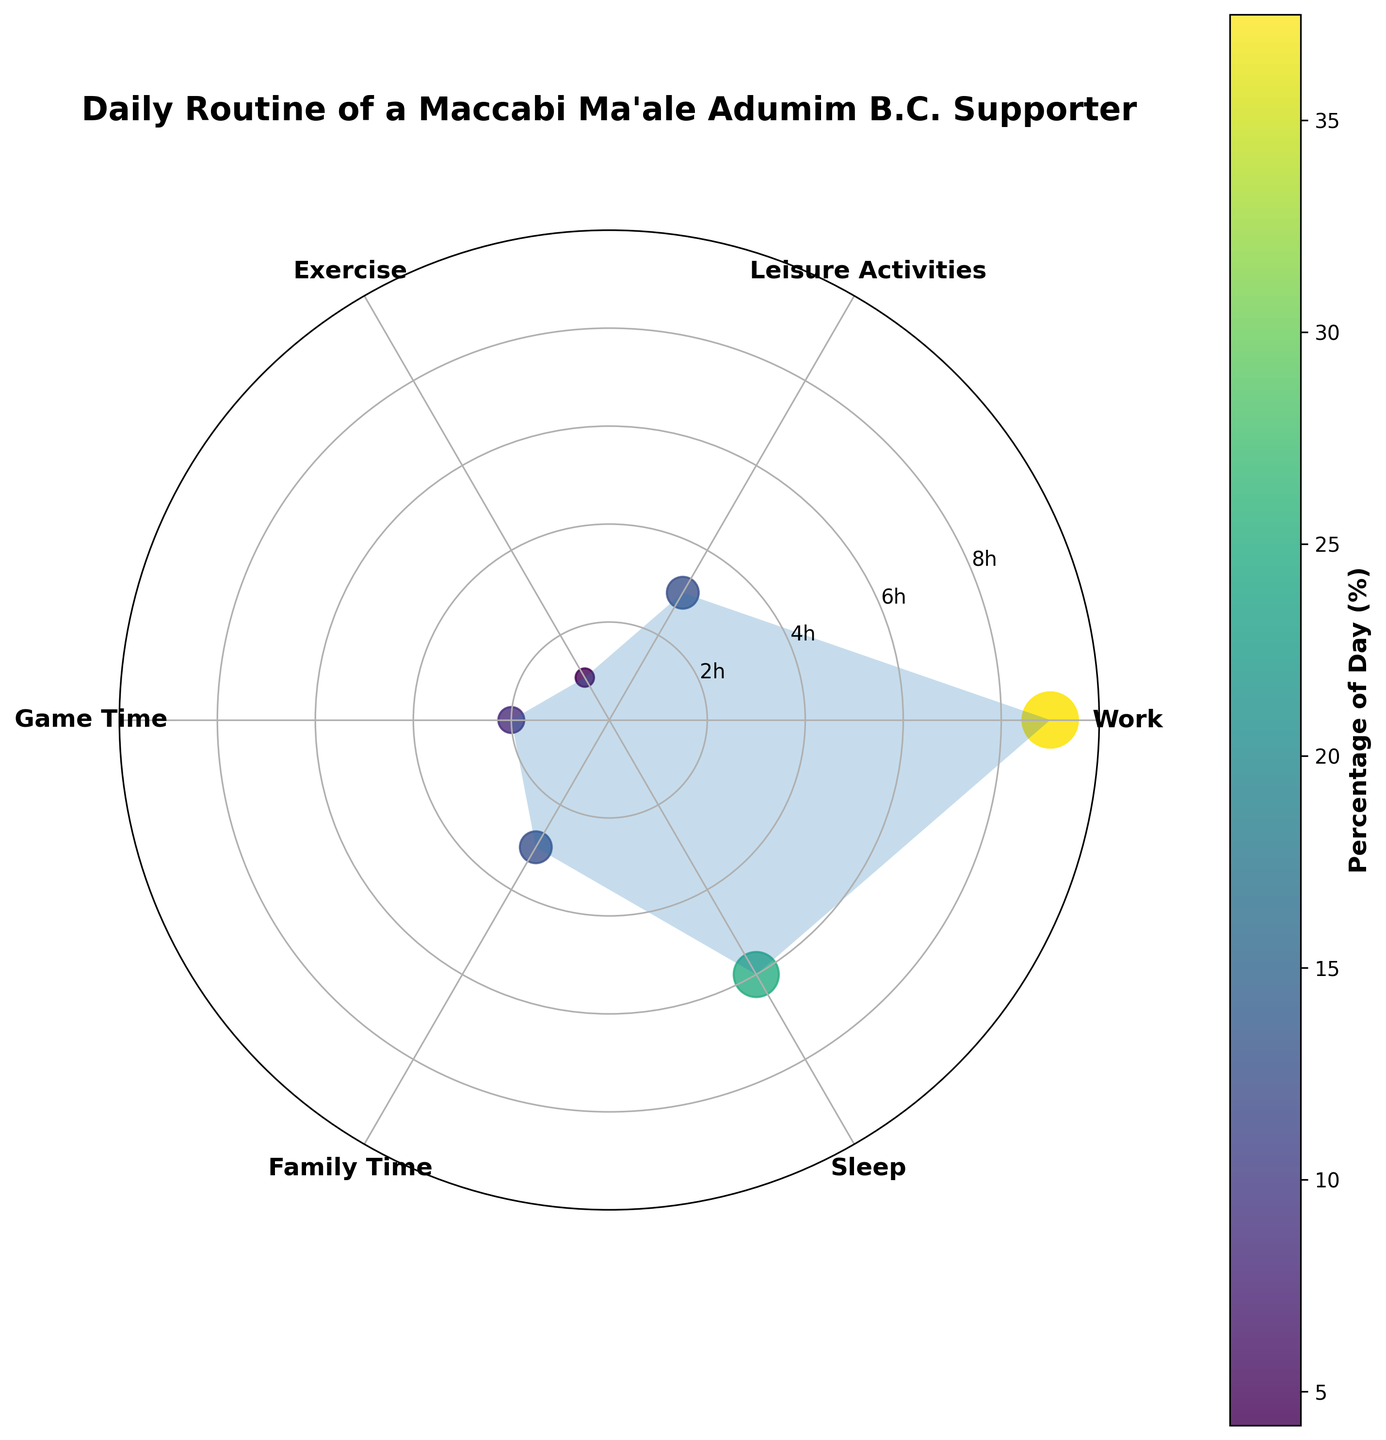Is "Work" the category with the highest number of hours spent? The figure shows different categories labeled around the polar chart with their corresponding hours marked by radial distances. "Work" appears to extend the furthest radially, indicating the highest number of hours spent.
Answer: Yes How many hours are spent on "Exercise"? The figure has radial labels indicating hours, and "Exercise" corresponds to the inner-most radial distance, indicating 1 hour spent.
Answer: 1 hour Which category occupies 25% of the day? The colorbar indicates the percentage of the day, and "Sleep" is color-coded to match the 25% label on the colorbar.
Answer: Sleep What is the total number of hours spent on "Leisure Activities" and "Game Time"? From the figure, "Leisure Activities" is indicated at 3 hours, and "Game Time" is at 2 hours. Summing these gives 3 + 2 = 5 hours.
Answer: 5 hours Is "Family Time" represented equally to any other category in terms of percentage of the day? From the percentages on the colorbar and the figure, "Family Time" (12.5%) is equal to "Leisure Activities" (12.5%).
Answer: Leisure Activities Which category is represented by the smallest circle in the scatter plot? The size of circles on the scatter plot corresponds to the percentage of the day. The smallest circle, being the smallest proportion, is for "Exercise" at 4.2%.
Answer: Exercise How do the hours spent on "Sleep" compare to those spent on "Work"? The polar scatter chart shows "Sleep" at 6 hours and "Work" at 9 hours. Comparing these, "Work" has 3 more hours than "Sleep".
Answer: Work has 3 more hours What is the average number of hours spent on "Game Time" and "Family Time"? From the chart, "Game Time" is 2 hours, and "Family Time" is 3 hours. The average is calculated by (2 + 3) / 2 = 2.5 hours.
Answer: 2.5 hours What is the combined percentage of the day spent on "Exercise" and "Game Time"? From the colorbar and figure, "Exercise" is 4.2%, and "Game Time" is 8.3%. Adding these gives 4.2 + 8.3 = 12.5%.
Answer: 12.5% How many categories are represented in the polar scatter chart? The figure labels five different categories plotted around the polar chart: Work, Leisure Activities, Exercise, Game Time, Family Time, and Sleep. Counting these gives six categories.
Answer: 6 categories 